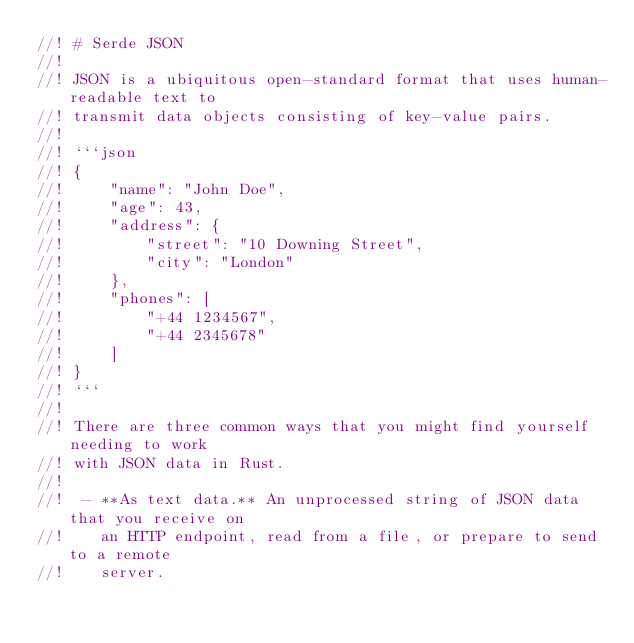<code> <loc_0><loc_0><loc_500><loc_500><_Rust_>//! # Serde JSON
//!
//! JSON is a ubiquitous open-standard format that uses human-readable text to
//! transmit data objects consisting of key-value pairs.
//!
//! ```json
//! {
//!     "name": "John Doe",
//!     "age": 43,
//!     "address": {
//!         "street": "10 Downing Street",
//!         "city": "London"
//!     },
//!     "phones": [
//!         "+44 1234567",
//!         "+44 2345678"
//!     ]
//! }
//! ```
//!
//! There are three common ways that you might find yourself needing to work
//! with JSON data in Rust.
//!
//!  - **As text data.** An unprocessed string of JSON data that you receive on
//!    an HTTP endpoint, read from a file, or prepare to send to a remote
//!    server.</code> 